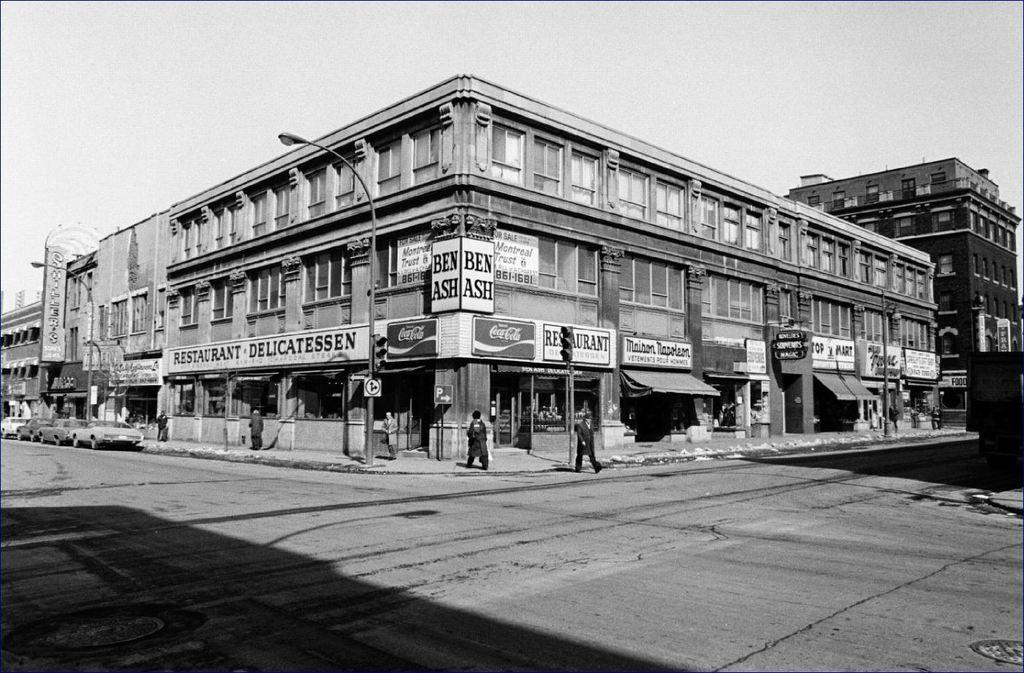Provide a one-sentence caption for the provided image. City view with a "BEN ASH" store in the corner. 